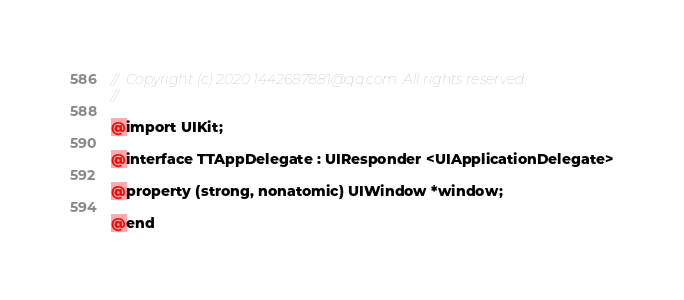Convert code to text. <code><loc_0><loc_0><loc_500><loc_500><_C_>//  Copyright (c) 2020 1442687881@qq.com. All rights reserved.
//

@import UIKit;

@interface TTAppDelegate : UIResponder <UIApplicationDelegate>

@property (strong, nonatomic) UIWindow *window;

@end
</code> 